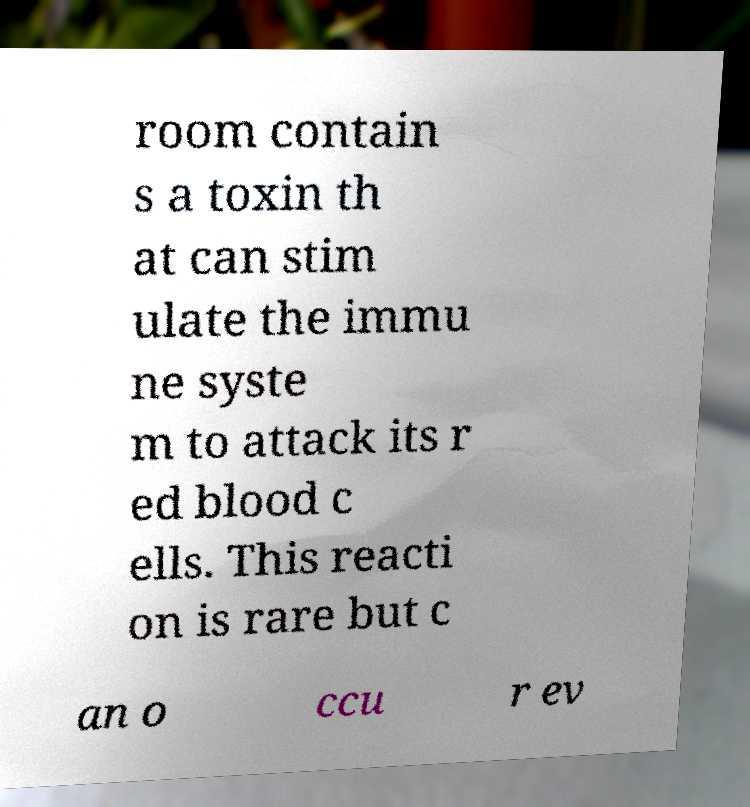There's text embedded in this image that I need extracted. Can you transcribe it verbatim? room contain s a toxin th at can stim ulate the immu ne syste m to attack its r ed blood c ells. This reacti on is rare but c an o ccu r ev 